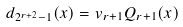Convert formula to latex. <formula><loc_0><loc_0><loc_500><loc_500>d _ { 2 ^ { r + 2 } - 1 } ( x ) = v _ { r + 1 } Q _ { r + 1 } ( x )</formula> 